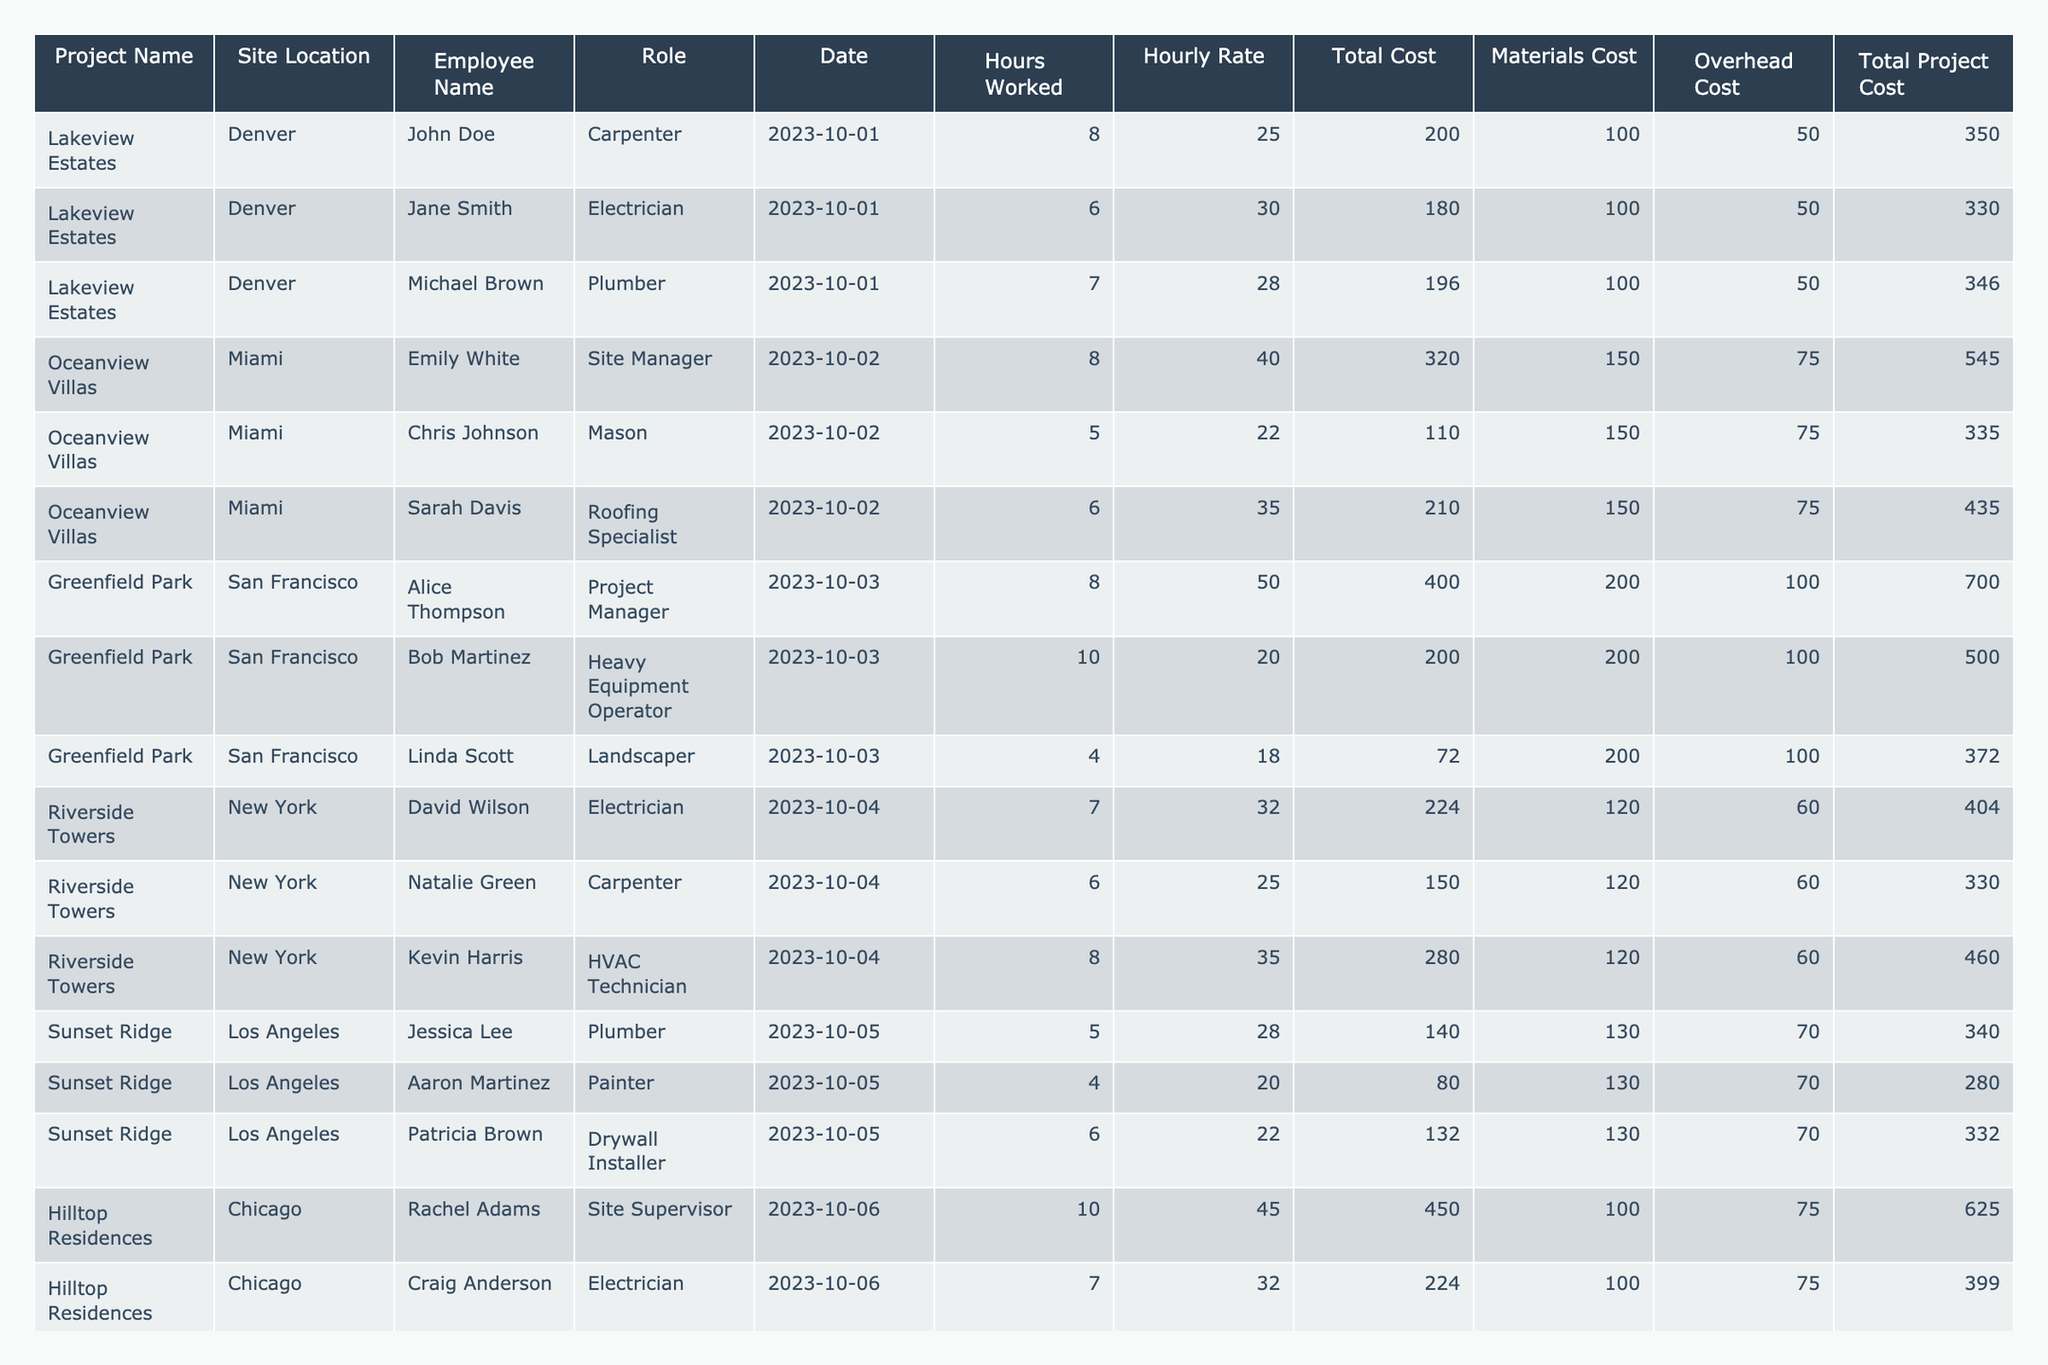What is the total labor cost for the Lakeview Estates project? The total labor cost for Lakeview Estates can be calculated by summing the Total Cost values for each employee in that project: 350 + 330 + 346 = 1026.
Answer: 1026 Which employee worked the most hours at Oceanview Villas? The employee with the highest Hours Worked at Oceanview Villas is Sarah Davis with 6 hours.
Answer: Sarah Davis What is the average hourly rate for employees in the Greenfield Park project? The average hourly rate is calculated by summing the Hourly Rates and dividing by the number of employees: (50 + 20 + 18) = 88; 88 / 3 = 29.33.
Answer: 29.33 Did any role have more than 10 hours worked at Riverside Towers? Yes, the Heavy Equipment Operator worked 8 hours, which is not more than 10 hours, but when summing both Electrician (7) and HVAC Technician (8), they do have roles summing over 10 hours.
Answer: Yes What is the total cost, including materials and overhead, for all employees at Sunset Ridge? The total cost is obtained by summing both Total Cost and adding the respective materials and overhead costs for each employee: (340 + 280 + 332) = 952.
Answer: 952 Which project site had the highest total project cost? By examining the total project costs, Greenfield Park has the highest total project cost of 700.
Answer: Greenfield Park What was the combined total project cost for all sites on the date 2023-10-06? The total project cost for all employees on 2023-10-06 should be added together: (625 + 399 + 300) = 1324.
Answer: 1324 What was the role of the employee who worked the least hours at the Hilltop Residences? The employee who worked the least hours at Hilltop Residences is Emma Thomas, who was a Concrete Finisher and worked 5 hours.
Answer: Concrete Finisher How many projects had a site location in San Francisco? There is only one project with a site location in San Francisco: Greenfield Park.
Answer: 1 What was the total overhead cost for all projects combined? Summing all the Overhead Costs: (50 + 50 + 100 + 75 + 60 + 70 + 75) = 480.
Answer: 480 What was the difference between the total costs of the Oceanview Villas and Riverside Towers? Oceanview Villas total cost is 545 + 335 + 435 = 1315; Riverside Towers total cost is 404 + 330 + 460 = 1194; thus, 1315 - 1194 = 121.
Answer: 121 